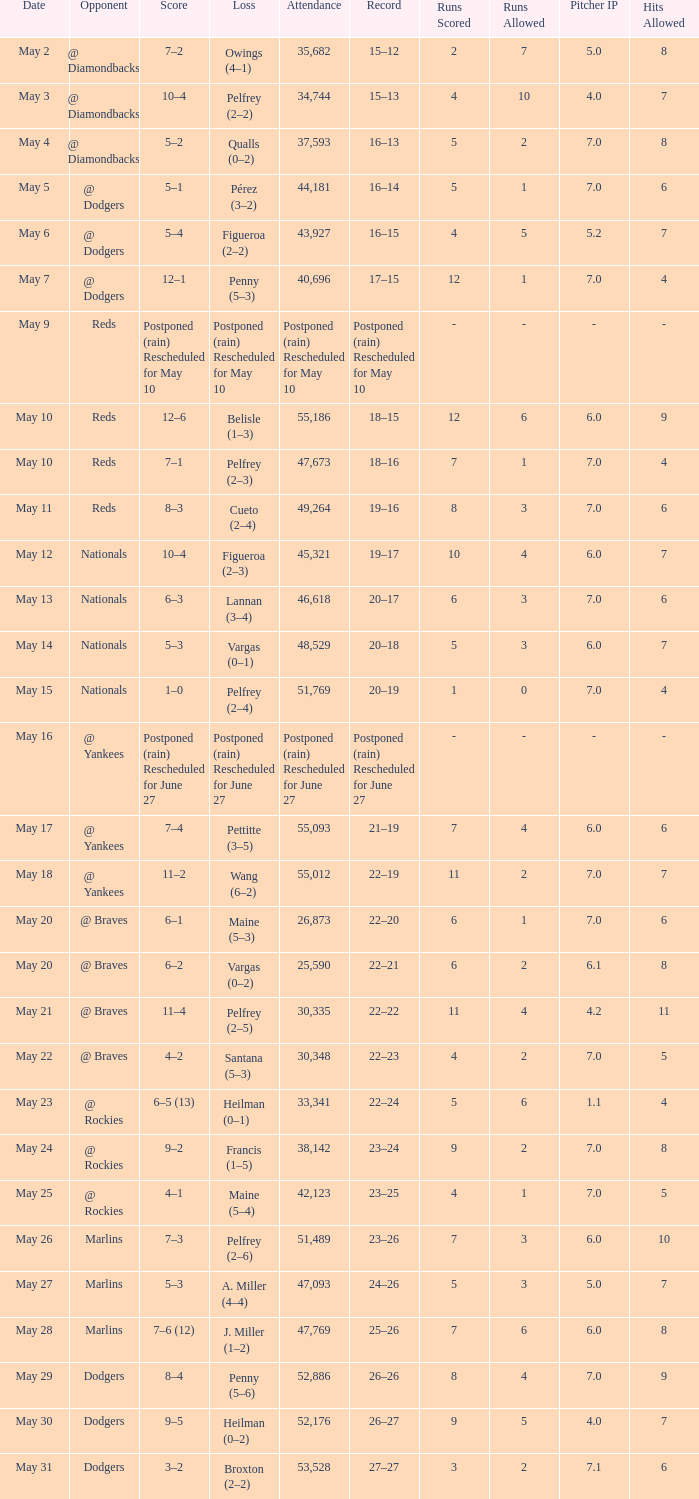Score of postponed (rain) rescheduled for June 27 had what loss? Postponed (rain) Rescheduled for June 27. Could you parse the entire table? {'header': ['Date', 'Opponent', 'Score', 'Loss', 'Attendance', 'Record', 'Runs Scored', 'Runs Allowed', 'Pitcher IP', 'Hits Allowed'], 'rows': [['May 2', '@ Diamondbacks', '7–2', 'Owings (4–1)', '35,682', '15–12', '2', '7', '5.0', '8'], ['May 3', '@ Diamondbacks', '10–4', 'Pelfrey (2–2)', '34,744', '15–13', '4', '10', '4.0', '7'], ['May 4', '@ Diamondbacks', '5–2', 'Qualls (0–2)', '37,593', '16–13', '5', '2', '7.0', '8'], ['May 5', '@ Dodgers', '5–1', 'Pérez (3–2)', '44,181', '16–14', '5', '1', '7.0', '6'], ['May 6', '@ Dodgers', '5–4', 'Figueroa (2–2)', '43,927', '16–15', '4', '5', '5.2', '7'], ['May 7', '@ Dodgers', '12–1', 'Penny (5–3)', '40,696', '17–15', '12', '1', '7.0', '4'], ['May 9', 'Reds', 'Postponed (rain) Rescheduled for May 10', 'Postponed (rain) Rescheduled for May 10', 'Postponed (rain) Rescheduled for May 10', 'Postponed (rain) Rescheduled for May 10', '-', '-', '-', '-'], ['May 10', 'Reds', '12–6', 'Belisle (1–3)', '55,186', '18–15', '12', '6', '6.0', '9'], ['May 10', 'Reds', '7–1', 'Pelfrey (2–3)', '47,673', '18–16', '7', '1', '7.0', '4'], ['May 11', 'Reds', '8–3', 'Cueto (2–4)', '49,264', '19–16', '8', '3', '7.0', '6'], ['May 12', 'Nationals', '10–4', 'Figueroa (2–3)', '45,321', '19–17', '10', '4', '6.0', '7'], ['May 13', 'Nationals', '6–3', 'Lannan (3–4)', '46,618', '20–17', '6', '3', '7.0', '6'], ['May 14', 'Nationals', '5–3', 'Vargas (0–1)', '48,529', '20–18', '5', '3', '6.0', '7'], ['May 15', 'Nationals', '1–0', 'Pelfrey (2–4)', '51,769', '20–19', '1', '0', '7.0', '4'], ['May 16', '@ Yankees', 'Postponed (rain) Rescheduled for June 27', 'Postponed (rain) Rescheduled for June 27', 'Postponed (rain) Rescheduled for June 27', 'Postponed (rain) Rescheduled for June 27', '-', '-', '-', '-'], ['May 17', '@ Yankees', '7–4', 'Pettitte (3–5)', '55,093', '21–19', '7', '4', '6.0', '6'], ['May 18', '@ Yankees', '11–2', 'Wang (6–2)', '55,012', '22–19', '11', '2', '7.0', '7'], ['May 20', '@ Braves', '6–1', 'Maine (5–3)', '26,873', '22–20', '6', '1', '7.0', '6'], ['May 20', '@ Braves', '6–2', 'Vargas (0–2)', '25,590', '22–21', '6', '2', '6.1', '8'], ['May 21', '@ Braves', '11–4', 'Pelfrey (2–5)', '30,335', '22–22', '11', '4', '4.2', '11'], ['May 22', '@ Braves', '4–2', 'Santana (5–3)', '30,348', '22–23', '4', '2', '7.0', '5'], ['May 23', '@ Rockies', '6–5 (13)', 'Heilman (0–1)', '33,341', '22–24', '5', '6', '1.1', '4'], ['May 24', '@ Rockies', '9–2', 'Francis (1–5)', '38,142', '23–24', '9', '2', '7.0', '8'], ['May 25', '@ Rockies', '4–1', 'Maine (5–4)', '42,123', '23–25', '4', '1', '7.0', '5'], ['May 26', 'Marlins', '7–3', 'Pelfrey (2–6)', '51,489', '23–26', '7', '3', '6.0', '10'], ['May 27', 'Marlins', '5–3', 'A. Miller (4–4)', '47,093', '24–26', '5', '3', '5.0', '7'], ['May 28', 'Marlins', '7–6 (12)', 'J. Miller (1–2)', '47,769', '25–26', '7', '6', '6.0', '8'], ['May 29', 'Dodgers', '8–4', 'Penny (5–6)', '52,886', '26–26', '8', '4', '7.0', '9'], ['May 30', 'Dodgers', '9–5', 'Heilman (0–2)', '52,176', '26–27', '9', '5', '4.0', '7'], ['May 31', 'Dodgers', '3–2', 'Broxton (2–2)', '53,528', '27–27', '3', '2', '7.1', '6']]} 